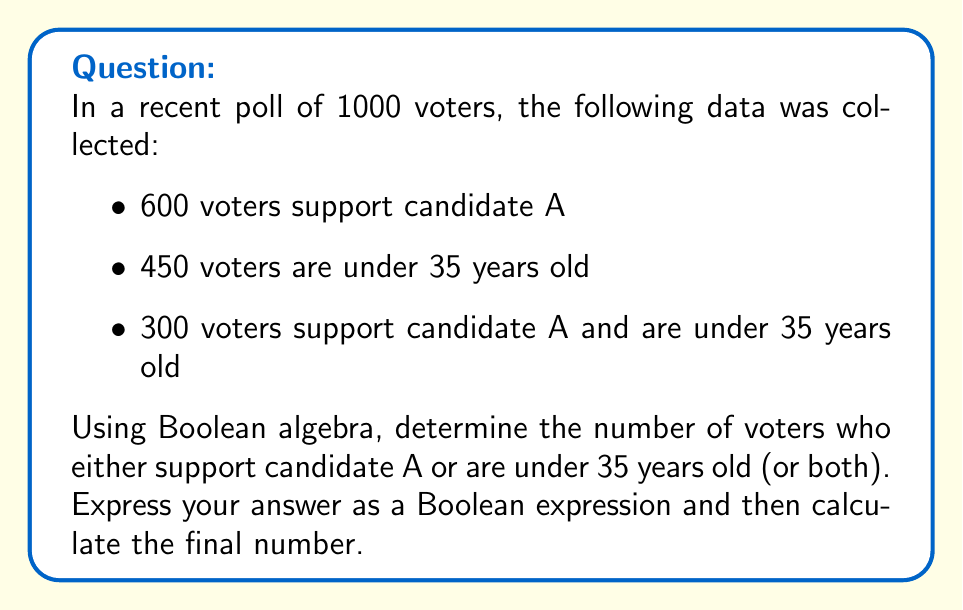Show me your answer to this math problem. Let's approach this step-by-step using Boolean algebra:

1) Define our sets:
   A = voters who support candidate A
   U = voters under 35 years old

2) We're looking for $|A \cup U|$, which represents the number of voters who support candidate A OR are under 35 (or both).

3) We can use the inclusion-exclusion principle:
   $|A \cup U| = |A| + |U| - |A \cap U|$

4) We know:
   $|A| = 600$
   $|U| = 450$
   $|A \cap U| = 300$

5) Substituting these values:
   $|A \cup U| = 600 + 450 - 300$

6) Calculating:
   $|A \cup U| = 750$

Therefore, 750 voters either support candidate A or are under 35 years old (or both).

This analysis helps identify a key demographic: voters who are either young or support candidate A, which could be crucial information for campaign strategy or political memoir writing.
Answer: $|A \cup U| = 750$ 